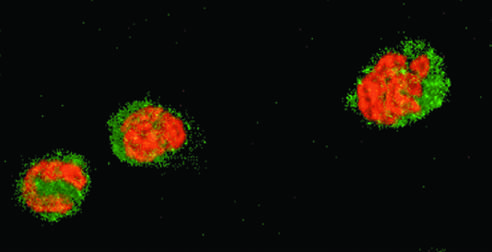re healthy neutrophils with nuclei stain red and cytoplasm green?
Answer the question using a single word or phrase. Yes 